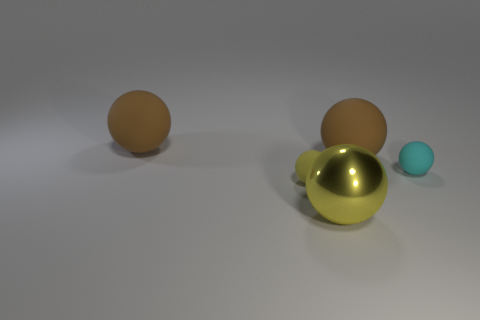What number of brown rubber things are the same shape as the big metallic thing? There are two brown rubber objects that share the same spherical shape as the larger metallic sphere in the image. 